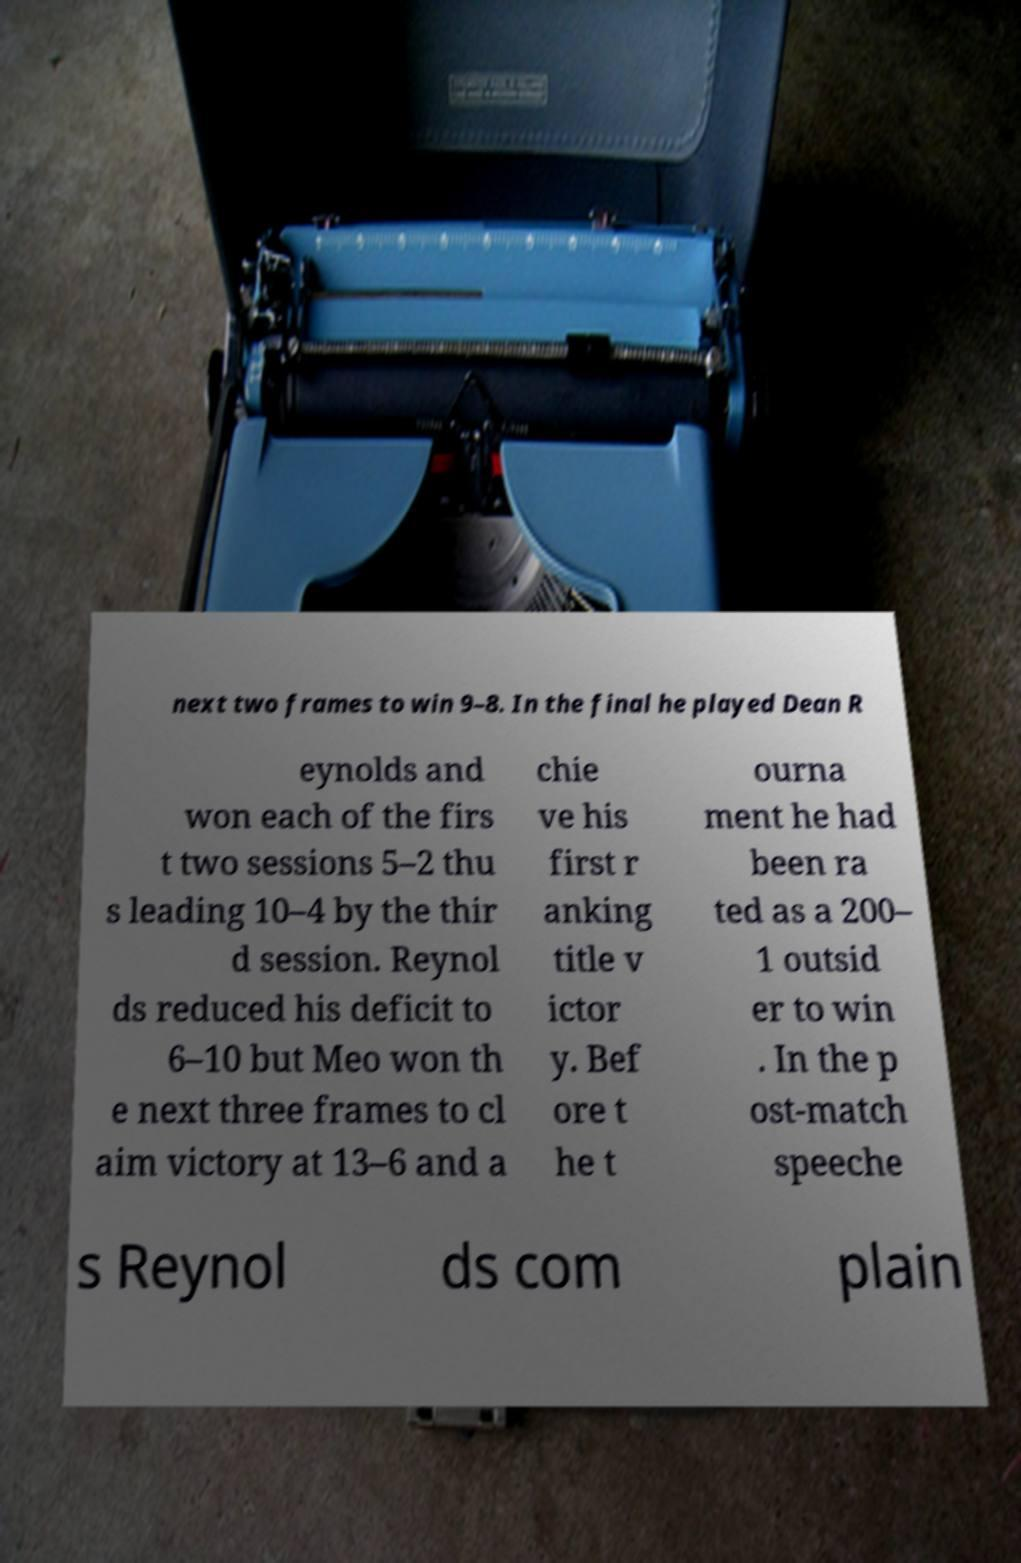There's text embedded in this image that I need extracted. Can you transcribe it verbatim? next two frames to win 9–8. In the final he played Dean R eynolds and won each of the firs t two sessions 5–2 thu s leading 10–4 by the thir d session. Reynol ds reduced his deficit to 6–10 but Meo won th e next three frames to cl aim victory at 13–6 and a chie ve his first r anking title v ictor y. Bef ore t he t ourna ment he had been ra ted as a 200– 1 outsid er to win . In the p ost-match speeche s Reynol ds com plain 